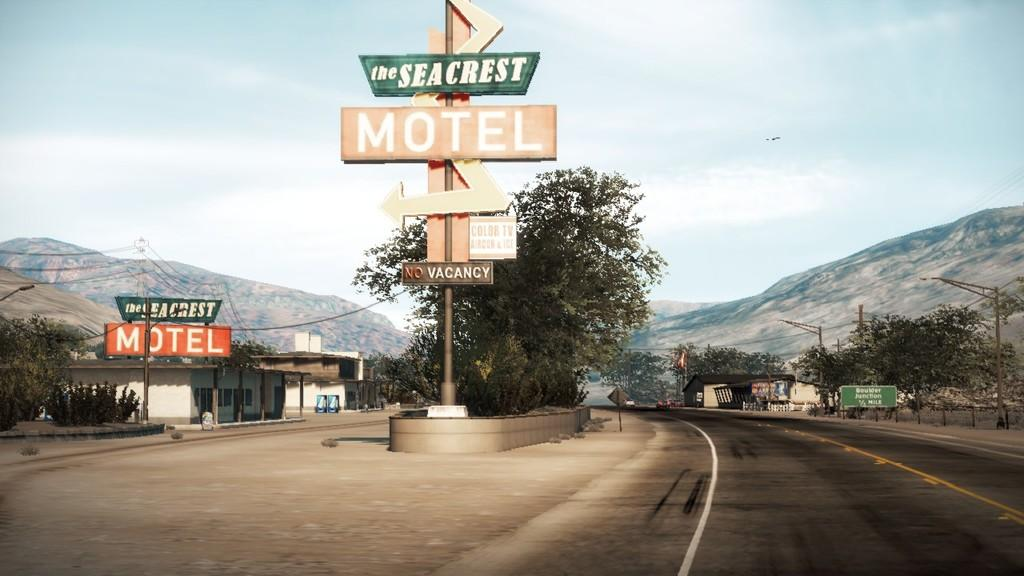<image>
Relay a brief, clear account of the picture shown. Several signs display the Seacrest Motel has color TV. 